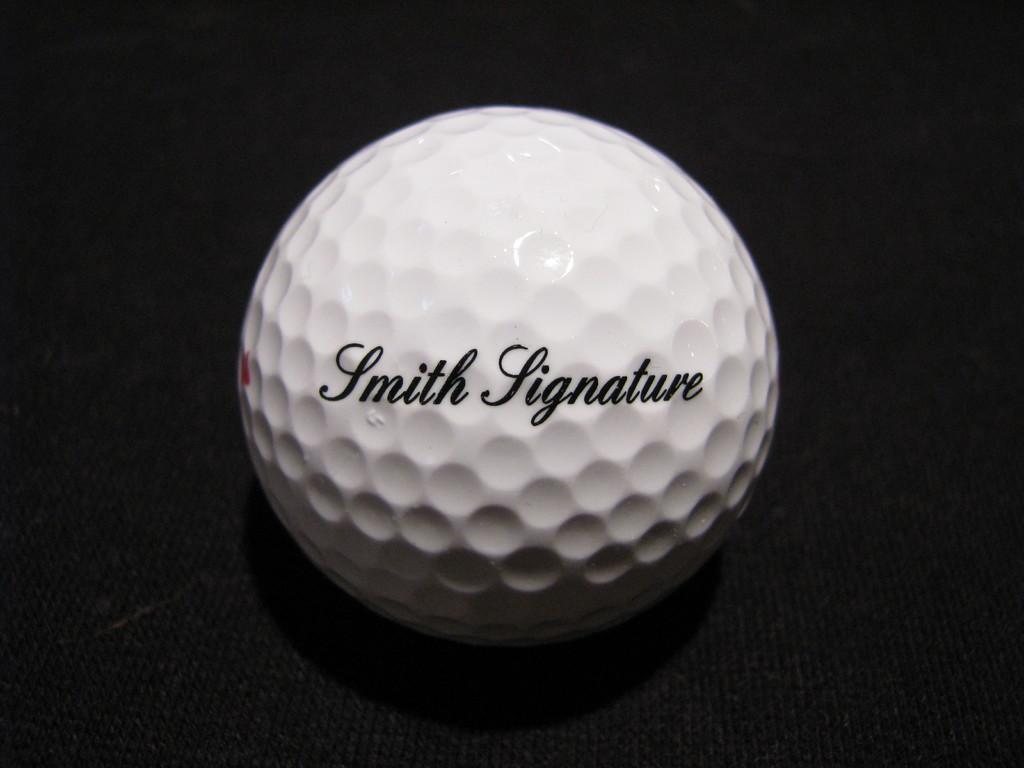Describe this image in one or two sentences. In this picture we can see a white ball on the black object and on the white ball it is written as " Smith Signature". 